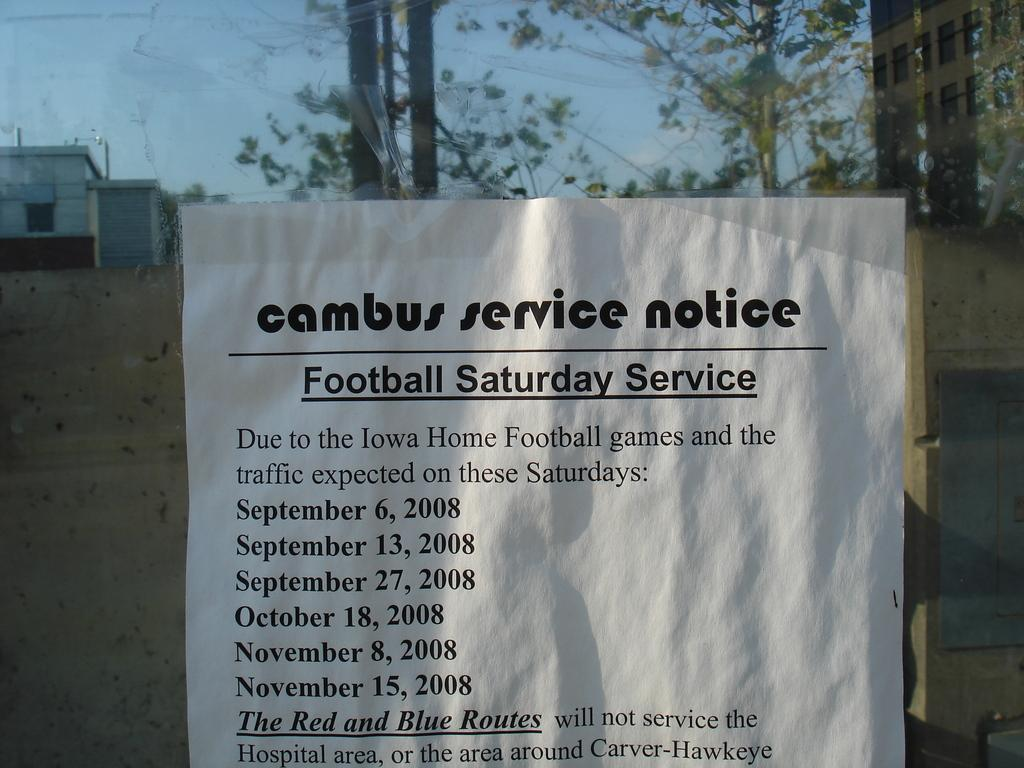What is the main subject in the center of the image? There is a notice in the center of the image. What can be seen in the background of the image? There are buildings and trees in the background of the image. What type of berry is used to decorate the edge of the notice in the image? There are no berries present in the image, as it features a notice with no decorations. 